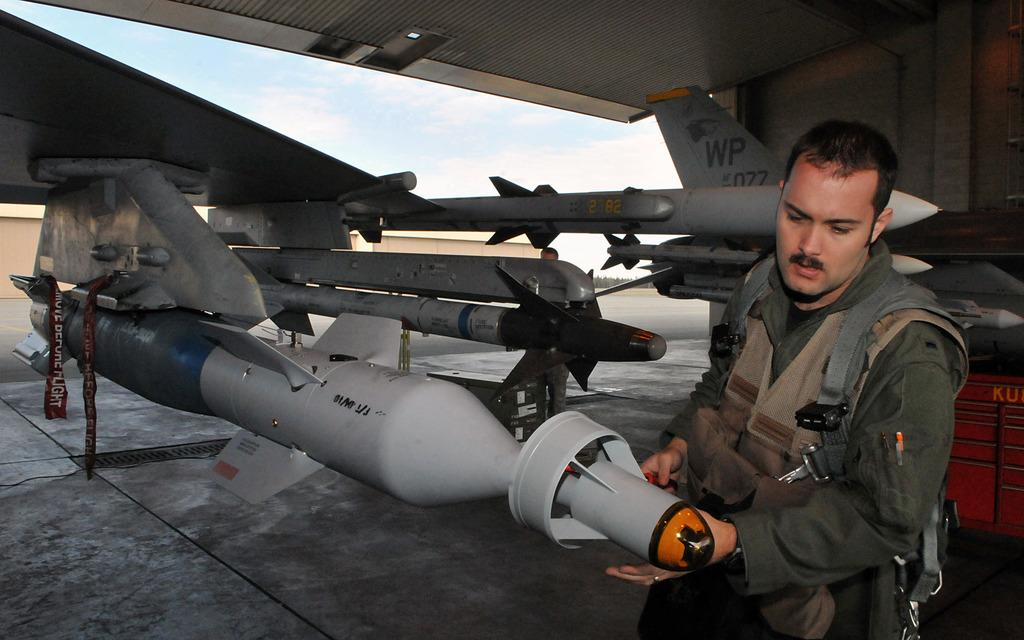<image>
Give a short and clear explanation of the subsequent image. a military person in front of military weapons and a plane tail fin reading WP 